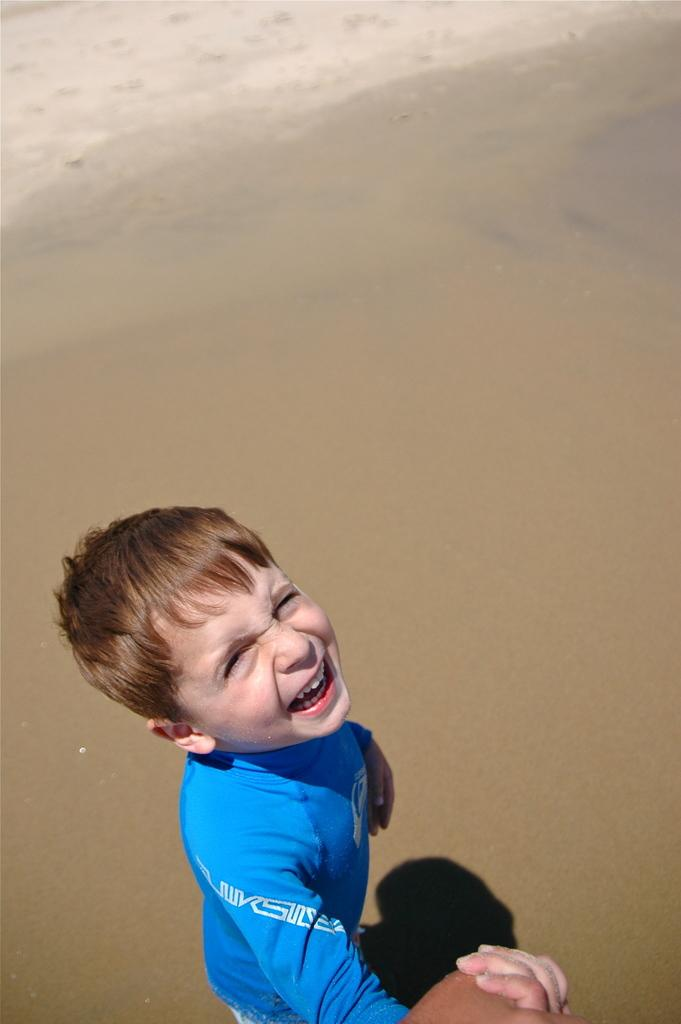Who is the main subject in the image? There is a boy in the image. What is the boy wearing? The boy is wearing a blue t-shirt. What type of surface is the boy walking on? The boy is walking on the sand. What type of hook is the boy using to catch fish in the image? There is no hook or fishing activity present in the image; the boy is simply walking on the sand. 